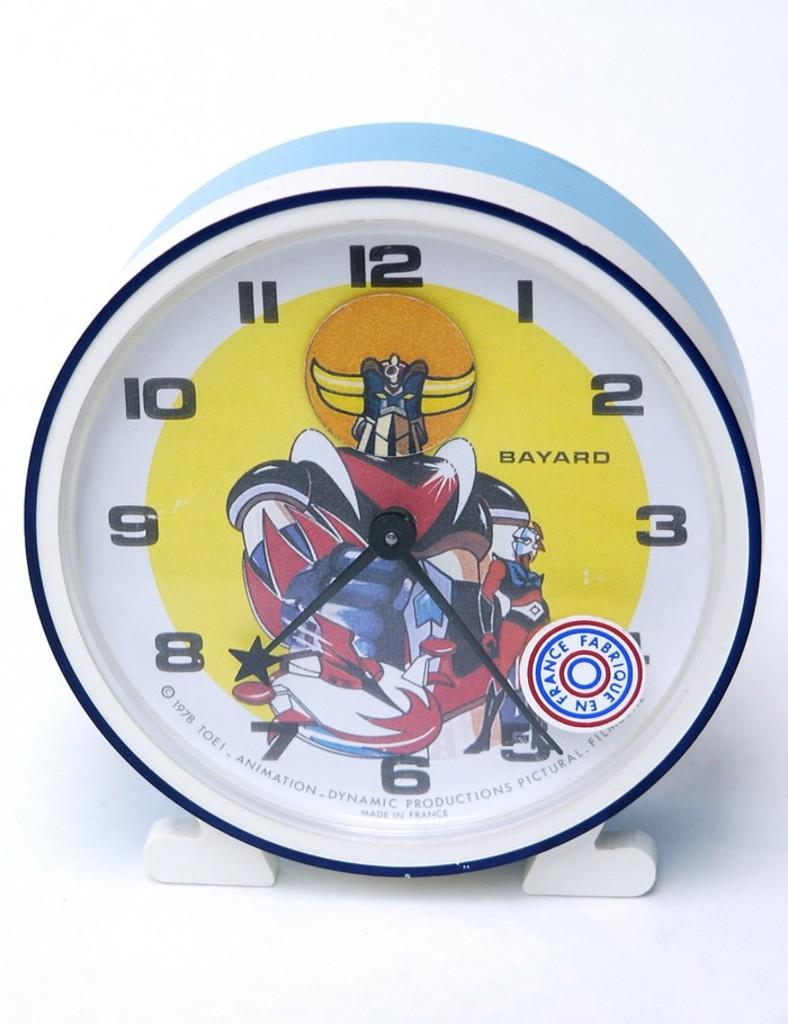<image>
Render a clear and concise summary of the photo. A white superhero clock that has a sticker on it that says Fabrique en France 